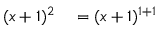Convert formula to latex. <formula><loc_0><loc_0><loc_500><loc_500>\begin{array} { r l r l } { ( x + 1 ) ^ { 2 } } & = ( x + 1 ) ^ { 1 + 1 } } \end{array}</formula> 